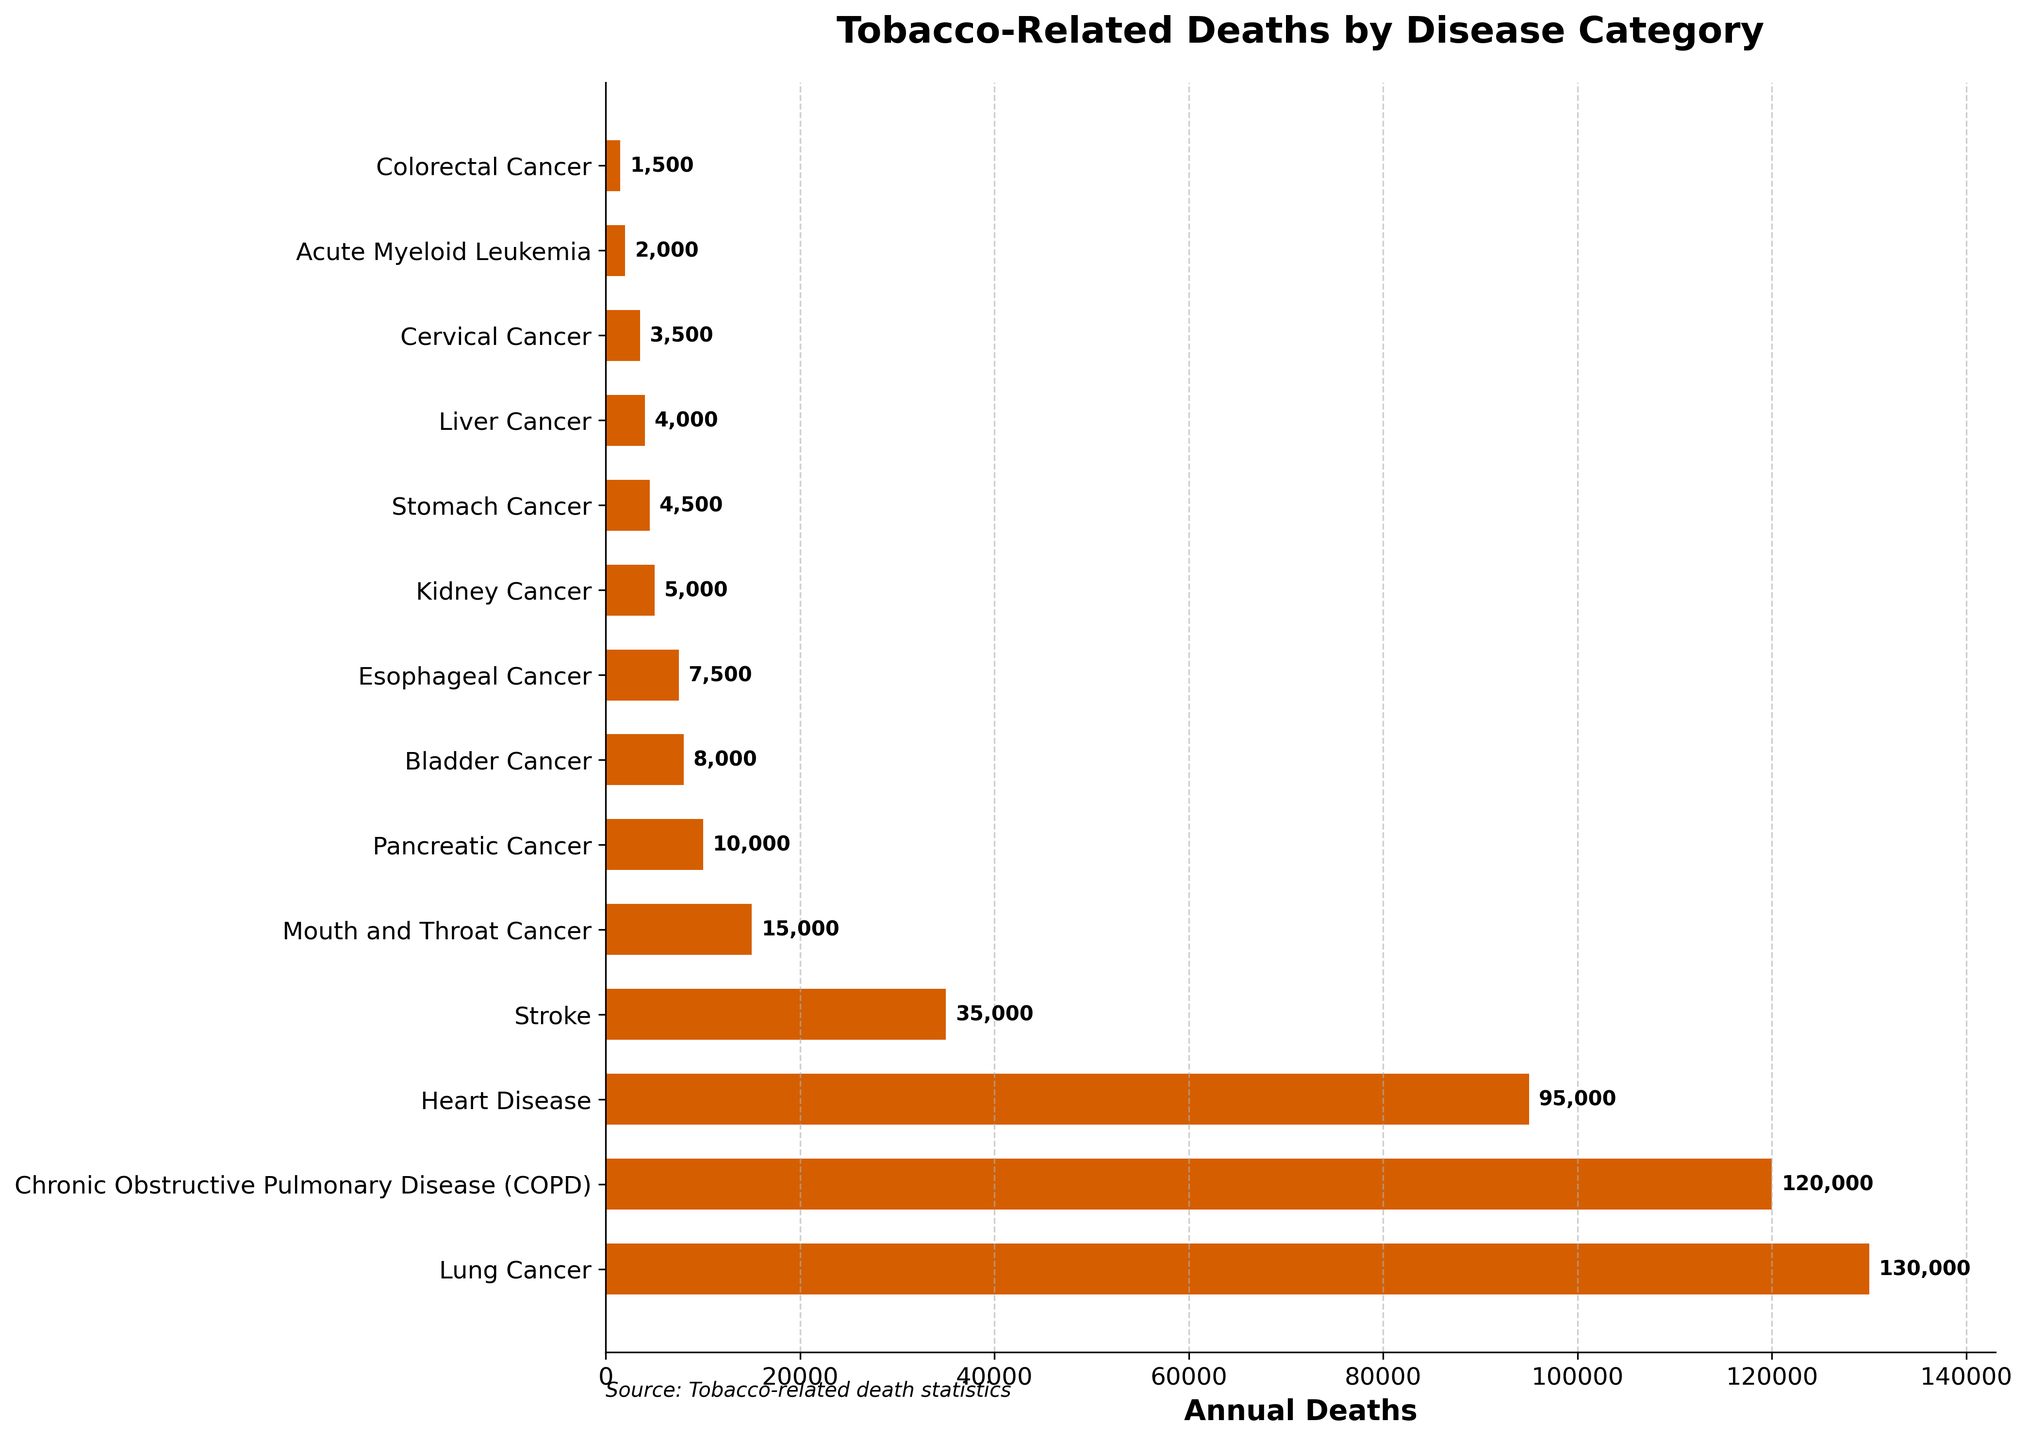Which disease category has the highest number of tobacco-related deaths? The bar representing "Lung Cancer" is the longest, indicating the highest number of deaths.
Answer: Lung Cancer What is the difference in tobacco-related deaths between Lung Cancer and COPD? Lung Cancer has 130,000 deaths and COPD has 120,000 deaths. The difference is 130,000 - 120,000 = 10,000.
Answer: 10,000 Which two disease categories have nearly equal numbers of tobacco-related deaths? The bars for "Lung Cancer" and "COPD" are very close in length, representing 130,000 and 120,000 deaths respectively.
Answer: Lung Cancer and COPD How many more tobacco-related deaths does Heart Disease have compared to Esophageal Cancer? Heart Disease has 95,000 deaths and Esophageal Cancer has 7,500 deaths. The difference is 95,000 - 7,500 = 87,500.
Answer: 87,500 What are the combined tobacco-related deaths for Kidney Cancer and Stomach Cancer? Kidney Cancer has 5,000 deaths and Stomach Cancer has 4,500 deaths. The sum is 5,000 + 4,500 = 9,500.
Answer: 9,500 How many disease categories have fewer than 10,000 tobacco-related deaths each? Disease categories with fewer than 10,000 deaths are Pancreatic Cancer (10,000), Bladder Cancer (8,000), Esophageal Cancer (7,500), Kidney Cancer (5,000), Stomach Cancer (4,500), Liver Cancer (4,000), Cervical Cancer (3,500), Acute Myeloid Leukemia (2,000), Colorectal Cancer (1,500), totaling 9 categories.
Answer: 9 Which disease category has the smallest number of tobacco-related deaths? The bar representing "Colorectal Cancer" is the shortest, indicating the smallest number of deaths.
Answer: Colorectal Cancer How does the number of tobacco-related deaths from Mouth and Throat Cancer compare to that of Pancreatic Cancer? Mouth and Throat Cancer has 15,000 deaths while Pancreatic Cancer has 10,000 deaths. Mouth and Throat Cancer has 5,000 more deaths.
Answer: Mouth and Throat Cancer has 5,000 more What is the average number of tobacco-related deaths among the top three disease categories? The top three categories are Lung Cancer (130,000), COPD (120,000), and Heart Disease (95,000). The sum is 130,000 + 120,000 + 95,000 = 345,000. The average is 345,000 / 3 = 115,000.
Answer: 115,000 What fraction of the total tobacco-related deaths is attributed to Stroke? The total number of deaths sums up to 440,000, and Stroke accounts for 35,000 of these. The fraction is 35,000 / 440,000 = 7.95% approximately.
Answer: 7.95% 